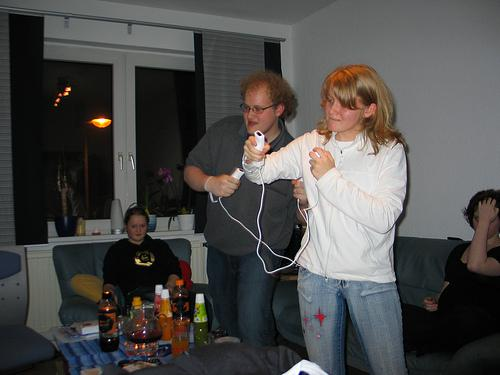Question: when was the picture taken?
Choices:
A. Morning.
B. Yesterday.
C. Night.
D. Last week.
Answer with the letter. Answer: C Question: where was the photo taken?
Choices:
A. In a living room.
B. In their bedroom.
C. On a beach.
D. Outside.
Answer with the letter. Answer: A Question: who is standing?
Choices:
A. My parents.
B. Two people.
C. The graduates.
D. My teacher.
Answer with the letter. Answer: B Question: what is in white color?
Choices:
A. The man's shoes.
B. The young girls headband.
C. The place mats.
D. The woman's shirt.
Answer with the letter. Answer: D Question: where are the street lamps?
Choices:
A. At the intersection outside.
B. Outside the window.
C. Outside of the house.
D. At the street sign.
Answer with the letter. Answer: B Question: how many people are sitting?
Choices:
A. Three.
B. Four.
C. Five.
D. Two.
Answer with the letter. Answer: D 